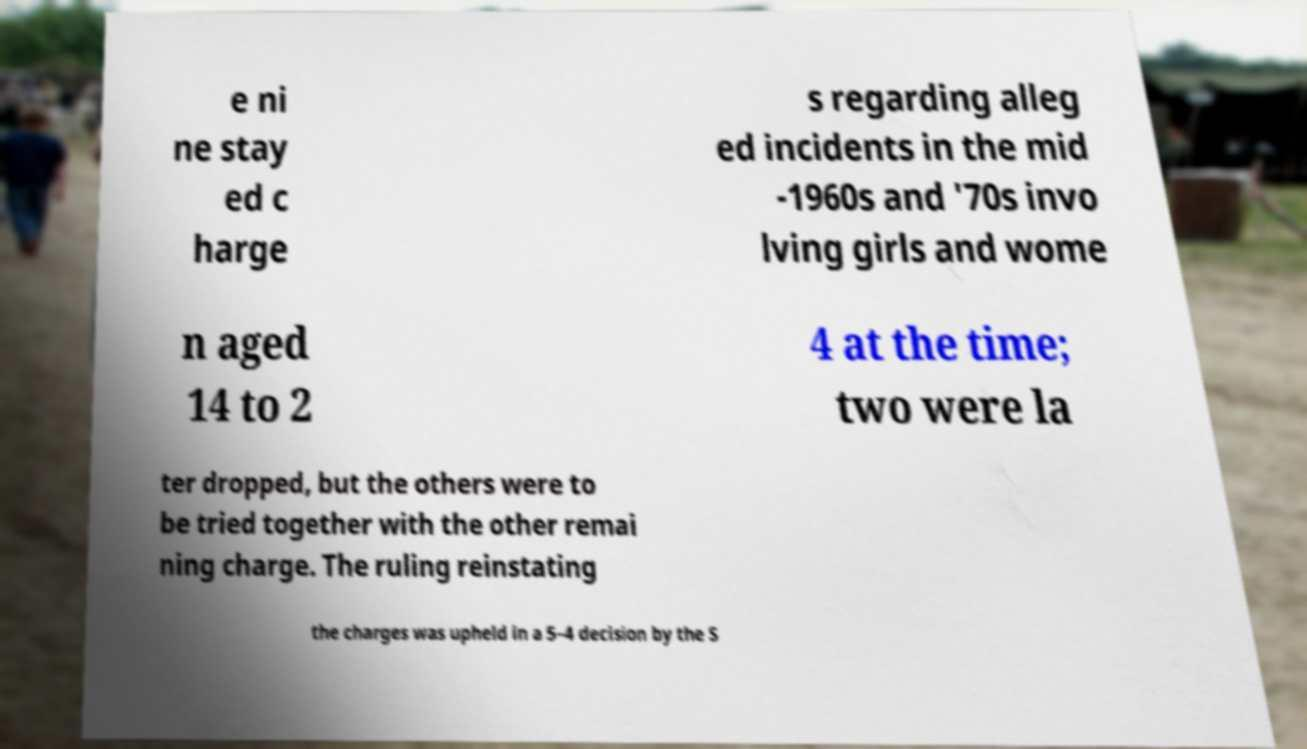Please read and relay the text visible in this image. What does it say? e ni ne stay ed c harge s regarding alleg ed incidents in the mid -1960s and '70s invo lving girls and wome n aged 14 to 2 4 at the time; two were la ter dropped, but the others were to be tried together with the other remai ning charge. The ruling reinstating the charges was upheld in a 5–4 decision by the S 